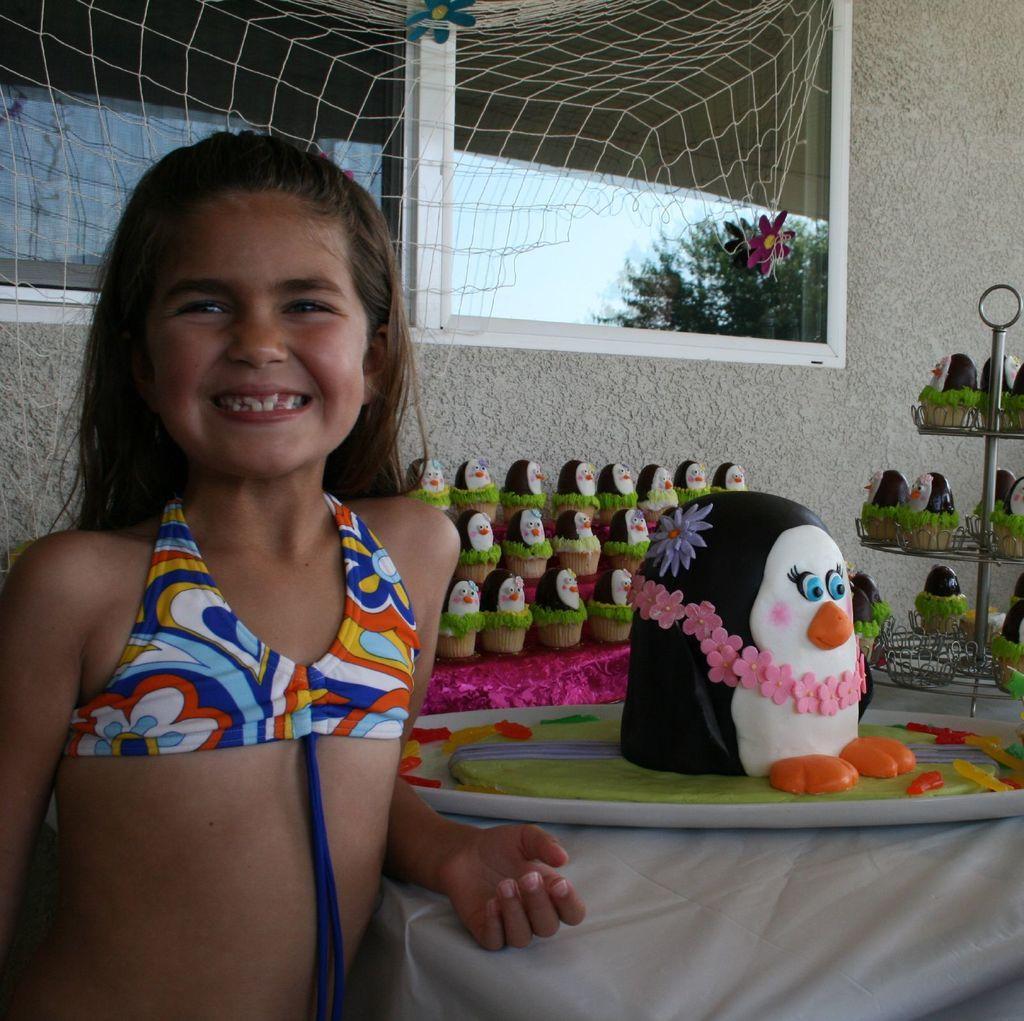Describe this image in one or two sentences. In this image we can see a girl standing and smiling. At the bottom there is a table and we can see figurines and a stand placed on the table. In the background there is a wall and we can see a window. There is a net. 